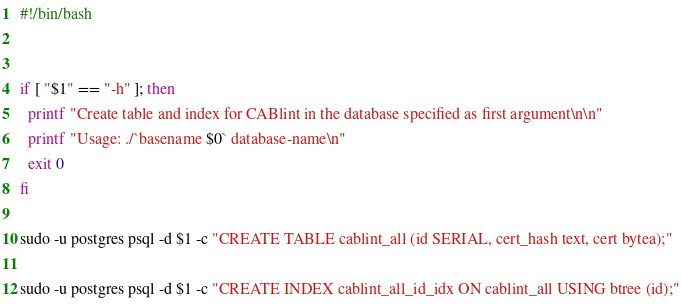Convert code to text. <code><loc_0><loc_0><loc_500><loc_500><_Bash_>#!/bin/bash


if [ "$1" == "-h" ]; then
  printf "Create table and index for CABlint in the database specified as first argument\n\n"
  printf "Usage: ./`basename $0` database-name\n"
  exit 0
fi

sudo -u postgres psql -d $1 -c "CREATE TABLE cablint_all (id SERIAL, cert_hash text, cert bytea);"

sudo -u postgres psql -d $1 -c "CREATE INDEX cablint_all_id_idx ON cablint_all USING btree (id);"

</code> 